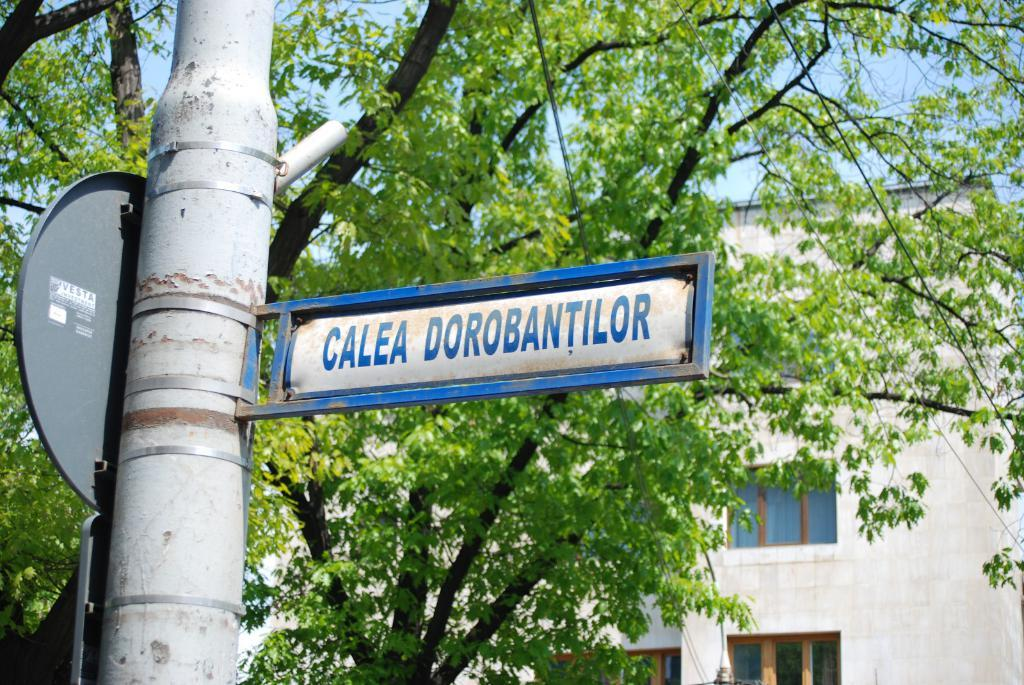<image>
Give a short and clear explanation of the subsequent image. A street sign in blue that says "Calea Dorobantilor" 